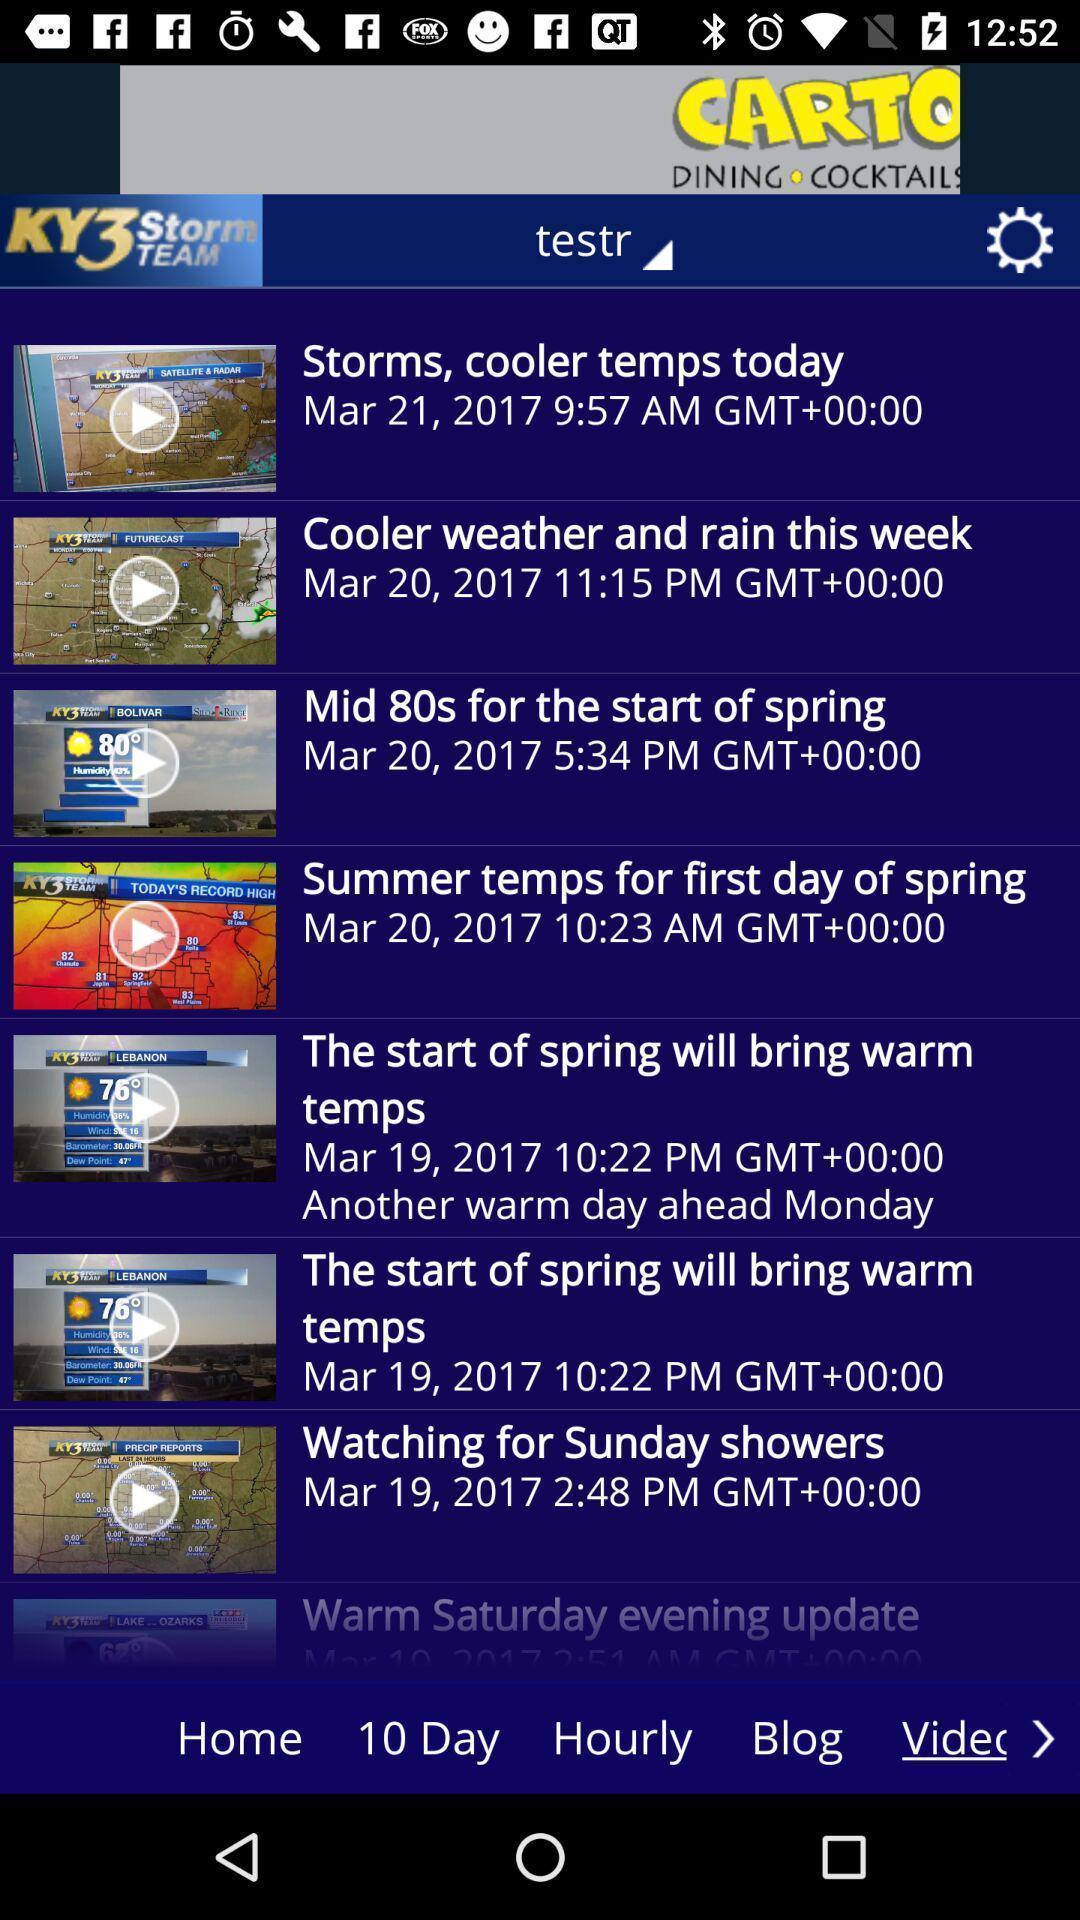Describe the visual elements of this screenshot. Screen shows list of videos in weather application. 